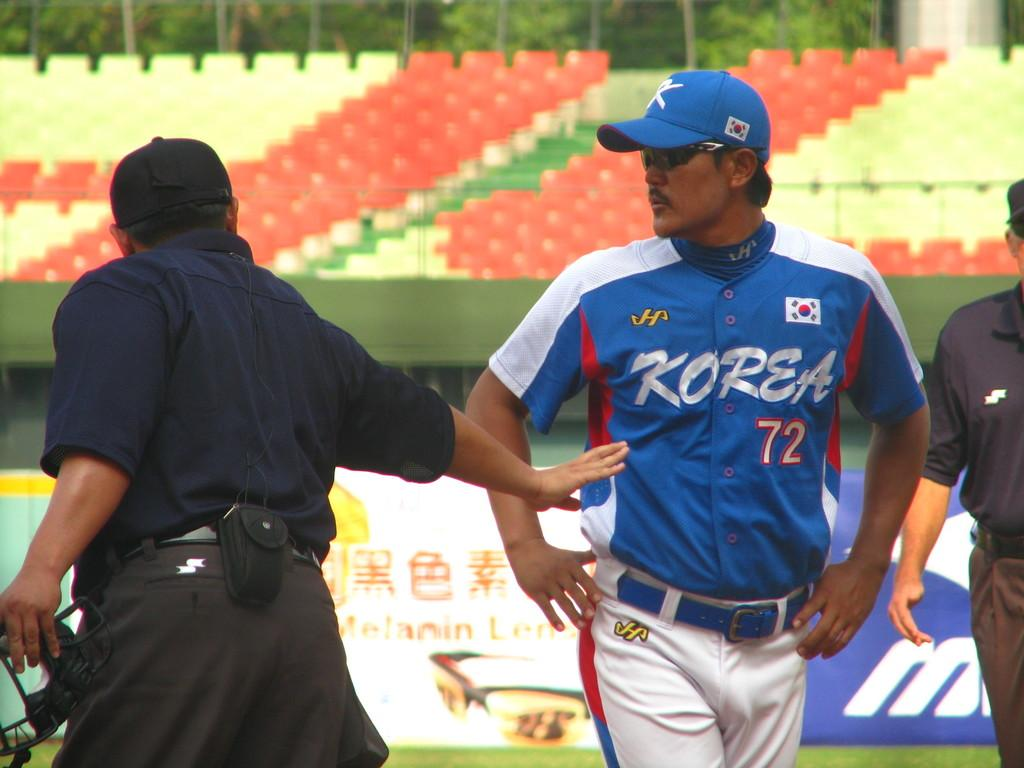<image>
Create a compact narrative representing the image presented. A baseball player earing number 72 and with Korea on his top is being told something by the referee 